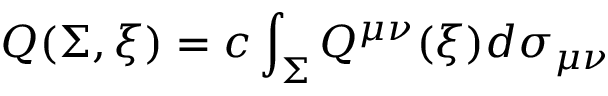<formula> <loc_0><loc_0><loc_500><loc_500>Q ( \Sigma , \xi ) = c \int _ { \Sigma } Q ^ { \mu \nu } ( \xi ) d \sigma _ { \mu \nu }</formula> 